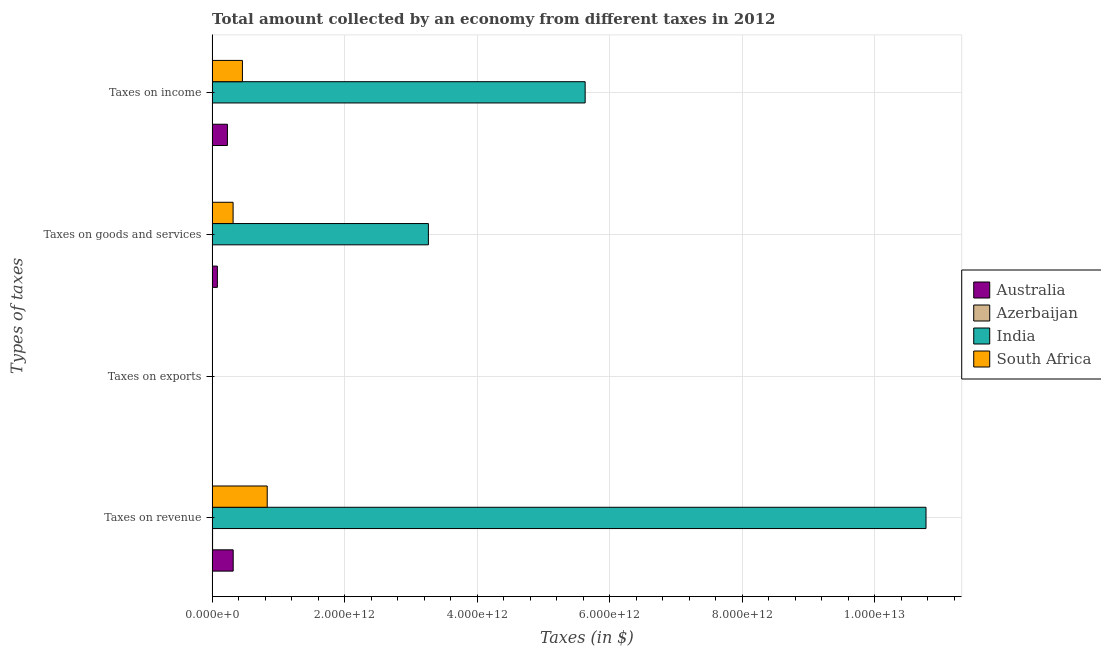How many different coloured bars are there?
Your answer should be compact. 4. How many groups of bars are there?
Offer a terse response. 4. How many bars are there on the 3rd tick from the top?
Provide a succinct answer. 4. What is the label of the 4th group of bars from the top?
Offer a terse response. Taxes on revenue. Across all countries, what is the maximum amount collected as tax on exports?
Keep it short and to the point. 7.00e+08. Across all countries, what is the minimum amount collected as tax on exports?
Provide a short and direct response. 8.00e+05. In which country was the amount collected as tax on income maximum?
Offer a very short reply. India. In which country was the amount collected as tax on goods minimum?
Your answer should be very brief. Azerbaijan. What is the total amount collected as tax on revenue in the graph?
Provide a succinct answer. 1.19e+13. What is the difference between the amount collected as tax on revenue in South Africa and that in Australia?
Give a very brief answer. 5.14e+11. What is the difference between the amount collected as tax on exports in South Africa and the amount collected as tax on income in India?
Offer a very short reply. -5.63e+12. What is the average amount collected as tax on revenue per country?
Give a very brief answer. 2.98e+12. What is the difference between the amount collected as tax on income and amount collected as tax on exports in Australia?
Provide a short and direct response. 2.31e+11. In how many countries, is the amount collected as tax on revenue greater than 7200000000000 $?
Offer a terse response. 1. What is the ratio of the amount collected as tax on exports in Australia to that in India?
Offer a terse response. 0.02. What is the difference between the highest and the second highest amount collected as tax on revenue?
Your answer should be very brief. 9.94e+12. What is the difference between the highest and the lowest amount collected as tax on income?
Ensure brevity in your answer.  5.63e+12. In how many countries, is the amount collected as tax on exports greater than the average amount collected as tax on exports taken over all countries?
Make the answer very short. 1. Is it the case that in every country, the sum of the amount collected as tax on income and amount collected as tax on exports is greater than the sum of amount collected as tax on revenue and amount collected as tax on goods?
Provide a succinct answer. No. What does the 4th bar from the top in Taxes on revenue represents?
Provide a short and direct response. Australia. Is it the case that in every country, the sum of the amount collected as tax on revenue and amount collected as tax on exports is greater than the amount collected as tax on goods?
Give a very brief answer. Yes. Are all the bars in the graph horizontal?
Your answer should be very brief. Yes. What is the difference between two consecutive major ticks on the X-axis?
Give a very brief answer. 2.00e+12. Does the graph contain any zero values?
Provide a short and direct response. No. Does the graph contain grids?
Give a very brief answer. Yes. How many legend labels are there?
Keep it short and to the point. 4. What is the title of the graph?
Ensure brevity in your answer.  Total amount collected by an economy from different taxes in 2012. What is the label or title of the X-axis?
Offer a very short reply. Taxes (in $). What is the label or title of the Y-axis?
Provide a succinct answer. Types of taxes. What is the Taxes (in $) in Australia in Taxes on revenue?
Offer a very short reply. 3.18e+11. What is the Taxes (in $) in Azerbaijan in Taxes on revenue?
Provide a succinct answer. 7.00e+09. What is the Taxes (in $) in India in Taxes on revenue?
Your answer should be compact. 1.08e+13. What is the Taxes (in $) in South Africa in Taxes on revenue?
Your response must be concise. 8.32e+11. What is the Taxes (in $) of India in Taxes on exports?
Give a very brief answer. 7.00e+08. What is the Taxes (in $) in South Africa in Taxes on exports?
Provide a succinct answer. 5.54e+07. What is the Taxes (in $) of Australia in Taxes on goods and services?
Your answer should be very brief. 7.94e+1. What is the Taxes (in $) in Azerbaijan in Taxes on goods and services?
Give a very brief answer. 3.08e+09. What is the Taxes (in $) of India in Taxes on goods and services?
Your answer should be compact. 3.26e+12. What is the Taxes (in $) in South Africa in Taxes on goods and services?
Your answer should be very brief. 3.17e+11. What is the Taxes (in $) in Australia in Taxes on income?
Provide a succinct answer. 2.31e+11. What is the Taxes (in $) in Azerbaijan in Taxes on income?
Your response must be concise. 3.07e+09. What is the Taxes (in $) of India in Taxes on income?
Your response must be concise. 5.63e+12. What is the Taxes (in $) in South Africa in Taxes on income?
Keep it short and to the point. 4.57e+11. Across all Types of taxes, what is the maximum Taxes (in $) of Australia?
Your answer should be compact. 3.18e+11. Across all Types of taxes, what is the maximum Taxes (in $) of Azerbaijan?
Offer a terse response. 7.00e+09. Across all Types of taxes, what is the maximum Taxes (in $) of India?
Ensure brevity in your answer.  1.08e+13. Across all Types of taxes, what is the maximum Taxes (in $) in South Africa?
Your response must be concise. 8.32e+11. Across all Types of taxes, what is the minimum Taxes (in $) of India?
Ensure brevity in your answer.  7.00e+08. Across all Types of taxes, what is the minimum Taxes (in $) in South Africa?
Keep it short and to the point. 5.54e+07. What is the total Taxes (in $) in Australia in the graph?
Offer a terse response. 6.28e+11. What is the total Taxes (in $) of Azerbaijan in the graph?
Provide a short and direct response. 1.31e+1. What is the total Taxes (in $) of India in the graph?
Provide a succinct answer. 1.97e+13. What is the total Taxes (in $) of South Africa in the graph?
Offer a very short reply. 1.61e+12. What is the difference between the Taxes (in $) in Australia in Taxes on revenue and that in Taxes on exports?
Your response must be concise. 3.18e+11. What is the difference between the Taxes (in $) of Azerbaijan in Taxes on revenue and that in Taxes on exports?
Keep it short and to the point. 6.99e+09. What is the difference between the Taxes (in $) of India in Taxes on revenue and that in Taxes on exports?
Give a very brief answer. 1.08e+13. What is the difference between the Taxes (in $) of South Africa in Taxes on revenue and that in Taxes on exports?
Keep it short and to the point. 8.32e+11. What is the difference between the Taxes (in $) of Australia in Taxes on revenue and that in Taxes on goods and services?
Provide a succinct answer. 2.39e+11. What is the difference between the Taxes (in $) of Azerbaijan in Taxes on revenue and that in Taxes on goods and services?
Your response must be concise. 3.92e+09. What is the difference between the Taxes (in $) in India in Taxes on revenue and that in Taxes on goods and services?
Your answer should be compact. 7.51e+12. What is the difference between the Taxes (in $) of South Africa in Taxes on revenue and that in Taxes on goods and services?
Ensure brevity in your answer.  5.15e+11. What is the difference between the Taxes (in $) of Australia in Taxes on revenue and that in Taxes on income?
Offer a terse response. 8.70e+1. What is the difference between the Taxes (in $) in Azerbaijan in Taxes on revenue and that in Taxes on income?
Ensure brevity in your answer.  3.92e+09. What is the difference between the Taxes (in $) of India in Taxes on revenue and that in Taxes on income?
Ensure brevity in your answer.  5.15e+12. What is the difference between the Taxes (in $) in South Africa in Taxes on revenue and that in Taxes on income?
Offer a terse response. 3.74e+11. What is the difference between the Taxes (in $) of Australia in Taxes on exports and that in Taxes on goods and services?
Offer a very short reply. -7.93e+1. What is the difference between the Taxes (in $) of Azerbaijan in Taxes on exports and that in Taxes on goods and services?
Keep it short and to the point. -3.08e+09. What is the difference between the Taxes (in $) in India in Taxes on exports and that in Taxes on goods and services?
Offer a terse response. -3.26e+12. What is the difference between the Taxes (in $) of South Africa in Taxes on exports and that in Taxes on goods and services?
Offer a very short reply. -3.16e+11. What is the difference between the Taxes (in $) of Australia in Taxes on exports and that in Taxes on income?
Provide a short and direct response. -2.31e+11. What is the difference between the Taxes (in $) in Azerbaijan in Taxes on exports and that in Taxes on income?
Your answer should be very brief. -3.07e+09. What is the difference between the Taxes (in $) of India in Taxes on exports and that in Taxes on income?
Provide a succinct answer. -5.63e+12. What is the difference between the Taxes (in $) of South Africa in Taxes on exports and that in Taxes on income?
Offer a very short reply. -4.57e+11. What is the difference between the Taxes (in $) in Australia in Taxes on goods and services and that in Taxes on income?
Provide a succinct answer. -1.51e+11. What is the difference between the Taxes (in $) in Azerbaijan in Taxes on goods and services and that in Taxes on income?
Ensure brevity in your answer.  7.40e+06. What is the difference between the Taxes (in $) of India in Taxes on goods and services and that in Taxes on income?
Offer a very short reply. -2.37e+12. What is the difference between the Taxes (in $) in South Africa in Taxes on goods and services and that in Taxes on income?
Ensure brevity in your answer.  -1.41e+11. What is the difference between the Taxes (in $) of Australia in Taxes on revenue and the Taxes (in $) of Azerbaijan in Taxes on exports?
Keep it short and to the point. 3.18e+11. What is the difference between the Taxes (in $) of Australia in Taxes on revenue and the Taxes (in $) of India in Taxes on exports?
Give a very brief answer. 3.17e+11. What is the difference between the Taxes (in $) of Australia in Taxes on revenue and the Taxes (in $) of South Africa in Taxes on exports?
Provide a short and direct response. 3.18e+11. What is the difference between the Taxes (in $) of Azerbaijan in Taxes on revenue and the Taxes (in $) of India in Taxes on exports?
Provide a short and direct response. 6.30e+09. What is the difference between the Taxes (in $) in Azerbaijan in Taxes on revenue and the Taxes (in $) in South Africa in Taxes on exports?
Provide a succinct answer. 6.94e+09. What is the difference between the Taxes (in $) of India in Taxes on revenue and the Taxes (in $) of South Africa in Taxes on exports?
Ensure brevity in your answer.  1.08e+13. What is the difference between the Taxes (in $) of Australia in Taxes on revenue and the Taxes (in $) of Azerbaijan in Taxes on goods and services?
Ensure brevity in your answer.  3.15e+11. What is the difference between the Taxes (in $) of Australia in Taxes on revenue and the Taxes (in $) of India in Taxes on goods and services?
Provide a succinct answer. -2.95e+12. What is the difference between the Taxes (in $) of Australia in Taxes on revenue and the Taxes (in $) of South Africa in Taxes on goods and services?
Make the answer very short. 1.33e+09. What is the difference between the Taxes (in $) in Azerbaijan in Taxes on revenue and the Taxes (in $) in India in Taxes on goods and services?
Give a very brief answer. -3.26e+12. What is the difference between the Taxes (in $) of Azerbaijan in Taxes on revenue and the Taxes (in $) of South Africa in Taxes on goods and services?
Give a very brief answer. -3.10e+11. What is the difference between the Taxes (in $) of India in Taxes on revenue and the Taxes (in $) of South Africa in Taxes on goods and services?
Ensure brevity in your answer.  1.05e+13. What is the difference between the Taxes (in $) in Australia in Taxes on revenue and the Taxes (in $) in Azerbaijan in Taxes on income?
Give a very brief answer. 3.15e+11. What is the difference between the Taxes (in $) of Australia in Taxes on revenue and the Taxes (in $) of India in Taxes on income?
Provide a short and direct response. -5.31e+12. What is the difference between the Taxes (in $) of Australia in Taxes on revenue and the Taxes (in $) of South Africa in Taxes on income?
Ensure brevity in your answer.  -1.39e+11. What is the difference between the Taxes (in $) of Azerbaijan in Taxes on revenue and the Taxes (in $) of India in Taxes on income?
Make the answer very short. -5.62e+12. What is the difference between the Taxes (in $) of Azerbaijan in Taxes on revenue and the Taxes (in $) of South Africa in Taxes on income?
Provide a succinct answer. -4.50e+11. What is the difference between the Taxes (in $) of India in Taxes on revenue and the Taxes (in $) of South Africa in Taxes on income?
Provide a succinct answer. 1.03e+13. What is the difference between the Taxes (in $) of Australia in Taxes on exports and the Taxes (in $) of Azerbaijan in Taxes on goods and services?
Your answer should be very brief. -3.07e+09. What is the difference between the Taxes (in $) in Australia in Taxes on exports and the Taxes (in $) in India in Taxes on goods and services?
Make the answer very short. -3.26e+12. What is the difference between the Taxes (in $) in Australia in Taxes on exports and the Taxes (in $) in South Africa in Taxes on goods and services?
Provide a short and direct response. -3.17e+11. What is the difference between the Taxes (in $) in Azerbaijan in Taxes on exports and the Taxes (in $) in India in Taxes on goods and services?
Your answer should be very brief. -3.26e+12. What is the difference between the Taxes (in $) of Azerbaijan in Taxes on exports and the Taxes (in $) of South Africa in Taxes on goods and services?
Your answer should be very brief. -3.17e+11. What is the difference between the Taxes (in $) of India in Taxes on exports and the Taxes (in $) of South Africa in Taxes on goods and services?
Give a very brief answer. -3.16e+11. What is the difference between the Taxes (in $) of Australia in Taxes on exports and the Taxes (in $) of Azerbaijan in Taxes on income?
Provide a succinct answer. -3.06e+09. What is the difference between the Taxes (in $) in Australia in Taxes on exports and the Taxes (in $) in India in Taxes on income?
Ensure brevity in your answer.  -5.63e+12. What is the difference between the Taxes (in $) in Australia in Taxes on exports and the Taxes (in $) in South Africa in Taxes on income?
Make the answer very short. -4.57e+11. What is the difference between the Taxes (in $) of Azerbaijan in Taxes on exports and the Taxes (in $) of India in Taxes on income?
Keep it short and to the point. -5.63e+12. What is the difference between the Taxes (in $) in Azerbaijan in Taxes on exports and the Taxes (in $) in South Africa in Taxes on income?
Offer a terse response. -4.57e+11. What is the difference between the Taxes (in $) in India in Taxes on exports and the Taxes (in $) in South Africa in Taxes on income?
Provide a short and direct response. -4.57e+11. What is the difference between the Taxes (in $) of Australia in Taxes on goods and services and the Taxes (in $) of Azerbaijan in Taxes on income?
Your answer should be very brief. 7.63e+1. What is the difference between the Taxes (in $) in Australia in Taxes on goods and services and the Taxes (in $) in India in Taxes on income?
Give a very brief answer. -5.55e+12. What is the difference between the Taxes (in $) in Australia in Taxes on goods and services and the Taxes (in $) in South Africa in Taxes on income?
Give a very brief answer. -3.78e+11. What is the difference between the Taxes (in $) in Azerbaijan in Taxes on goods and services and the Taxes (in $) in India in Taxes on income?
Ensure brevity in your answer.  -5.63e+12. What is the difference between the Taxes (in $) in Azerbaijan in Taxes on goods and services and the Taxes (in $) in South Africa in Taxes on income?
Your response must be concise. -4.54e+11. What is the difference between the Taxes (in $) of India in Taxes on goods and services and the Taxes (in $) of South Africa in Taxes on income?
Keep it short and to the point. 2.81e+12. What is the average Taxes (in $) of Australia per Types of taxes?
Provide a short and direct response. 1.57e+11. What is the average Taxes (in $) of Azerbaijan per Types of taxes?
Provide a succinct answer. 3.29e+09. What is the average Taxes (in $) in India per Types of taxes?
Keep it short and to the point. 4.92e+12. What is the average Taxes (in $) in South Africa per Types of taxes?
Make the answer very short. 4.01e+11. What is the difference between the Taxes (in $) in Australia and Taxes (in $) in Azerbaijan in Taxes on revenue?
Make the answer very short. 3.11e+11. What is the difference between the Taxes (in $) of Australia and Taxes (in $) of India in Taxes on revenue?
Give a very brief answer. -1.05e+13. What is the difference between the Taxes (in $) in Australia and Taxes (in $) in South Africa in Taxes on revenue?
Offer a terse response. -5.14e+11. What is the difference between the Taxes (in $) in Azerbaijan and Taxes (in $) in India in Taxes on revenue?
Provide a short and direct response. -1.08e+13. What is the difference between the Taxes (in $) of Azerbaijan and Taxes (in $) of South Africa in Taxes on revenue?
Keep it short and to the point. -8.25e+11. What is the difference between the Taxes (in $) of India and Taxes (in $) of South Africa in Taxes on revenue?
Make the answer very short. 9.94e+12. What is the difference between the Taxes (in $) in Australia and Taxes (in $) in Azerbaijan in Taxes on exports?
Make the answer very short. 1.12e+07. What is the difference between the Taxes (in $) in Australia and Taxes (in $) in India in Taxes on exports?
Your response must be concise. -6.88e+08. What is the difference between the Taxes (in $) in Australia and Taxes (in $) in South Africa in Taxes on exports?
Your response must be concise. -4.34e+07. What is the difference between the Taxes (in $) of Azerbaijan and Taxes (in $) of India in Taxes on exports?
Offer a very short reply. -6.99e+08. What is the difference between the Taxes (in $) of Azerbaijan and Taxes (in $) of South Africa in Taxes on exports?
Provide a short and direct response. -5.46e+07. What is the difference between the Taxes (in $) of India and Taxes (in $) of South Africa in Taxes on exports?
Your response must be concise. 6.45e+08. What is the difference between the Taxes (in $) in Australia and Taxes (in $) in Azerbaijan in Taxes on goods and services?
Provide a succinct answer. 7.63e+1. What is the difference between the Taxes (in $) of Australia and Taxes (in $) of India in Taxes on goods and services?
Ensure brevity in your answer.  -3.19e+12. What is the difference between the Taxes (in $) in Australia and Taxes (in $) in South Africa in Taxes on goods and services?
Provide a short and direct response. -2.37e+11. What is the difference between the Taxes (in $) in Azerbaijan and Taxes (in $) in India in Taxes on goods and services?
Give a very brief answer. -3.26e+12. What is the difference between the Taxes (in $) of Azerbaijan and Taxes (in $) of South Africa in Taxes on goods and services?
Provide a succinct answer. -3.13e+11. What is the difference between the Taxes (in $) of India and Taxes (in $) of South Africa in Taxes on goods and services?
Offer a terse response. 2.95e+12. What is the difference between the Taxes (in $) of Australia and Taxes (in $) of Azerbaijan in Taxes on income?
Your response must be concise. 2.28e+11. What is the difference between the Taxes (in $) in Australia and Taxes (in $) in India in Taxes on income?
Ensure brevity in your answer.  -5.40e+12. What is the difference between the Taxes (in $) in Australia and Taxes (in $) in South Africa in Taxes on income?
Offer a terse response. -2.26e+11. What is the difference between the Taxes (in $) of Azerbaijan and Taxes (in $) of India in Taxes on income?
Provide a short and direct response. -5.63e+12. What is the difference between the Taxes (in $) of Azerbaijan and Taxes (in $) of South Africa in Taxes on income?
Offer a terse response. -4.54e+11. What is the difference between the Taxes (in $) of India and Taxes (in $) of South Africa in Taxes on income?
Make the answer very short. 5.17e+12. What is the ratio of the Taxes (in $) in Australia in Taxes on revenue to that in Taxes on exports?
Provide a short and direct response. 2.65e+04. What is the ratio of the Taxes (in $) of Azerbaijan in Taxes on revenue to that in Taxes on exports?
Keep it short and to the point. 8744.38. What is the ratio of the Taxes (in $) of India in Taxes on revenue to that in Taxes on exports?
Offer a terse response. 1.54e+04. What is the ratio of the Taxes (in $) of South Africa in Taxes on revenue to that in Taxes on exports?
Ensure brevity in your answer.  1.50e+04. What is the ratio of the Taxes (in $) in Australia in Taxes on revenue to that in Taxes on goods and services?
Make the answer very short. 4.01. What is the ratio of the Taxes (in $) in Azerbaijan in Taxes on revenue to that in Taxes on goods and services?
Offer a terse response. 2.27. What is the ratio of the Taxes (in $) of India in Taxes on revenue to that in Taxes on goods and services?
Make the answer very short. 3.3. What is the ratio of the Taxes (in $) in South Africa in Taxes on revenue to that in Taxes on goods and services?
Your response must be concise. 2.63. What is the ratio of the Taxes (in $) of Australia in Taxes on revenue to that in Taxes on income?
Give a very brief answer. 1.38. What is the ratio of the Taxes (in $) in Azerbaijan in Taxes on revenue to that in Taxes on income?
Provide a succinct answer. 2.28. What is the ratio of the Taxes (in $) in India in Taxes on revenue to that in Taxes on income?
Your response must be concise. 1.91. What is the ratio of the Taxes (in $) of South Africa in Taxes on revenue to that in Taxes on income?
Offer a terse response. 1.82. What is the ratio of the Taxes (in $) in Azerbaijan in Taxes on exports to that in Taxes on goods and services?
Your answer should be compact. 0. What is the ratio of the Taxes (in $) in South Africa in Taxes on exports to that in Taxes on goods and services?
Offer a terse response. 0. What is the ratio of the Taxes (in $) in Australia in Taxes on exports to that in Taxes on income?
Your response must be concise. 0. What is the ratio of the Taxes (in $) of Azerbaijan in Taxes on exports to that in Taxes on income?
Provide a succinct answer. 0. What is the ratio of the Taxes (in $) of South Africa in Taxes on exports to that in Taxes on income?
Your answer should be very brief. 0. What is the ratio of the Taxes (in $) of Australia in Taxes on goods and services to that in Taxes on income?
Your answer should be compact. 0.34. What is the ratio of the Taxes (in $) in Azerbaijan in Taxes on goods and services to that in Taxes on income?
Make the answer very short. 1. What is the ratio of the Taxes (in $) of India in Taxes on goods and services to that in Taxes on income?
Give a very brief answer. 0.58. What is the ratio of the Taxes (in $) in South Africa in Taxes on goods and services to that in Taxes on income?
Provide a succinct answer. 0.69. What is the difference between the highest and the second highest Taxes (in $) in Australia?
Make the answer very short. 8.70e+1. What is the difference between the highest and the second highest Taxes (in $) in Azerbaijan?
Your answer should be compact. 3.92e+09. What is the difference between the highest and the second highest Taxes (in $) in India?
Your answer should be compact. 5.15e+12. What is the difference between the highest and the second highest Taxes (in $) in South Africa?
Offer a terse response. 3.74e+11. What is the difference between the highest and the lowest Taxes (in $) in Australia?
Your answer should be very brief. 3.18e+11. What is the difference between the highest and the lowest Taxes (in $) of Azerbaijan?
Make the answer very short. 6.99e+09. What is the difference between the highest and the lowest Taxes (in $) of India?
Give a very brief answer. 1.08e+13. What is the difference between the highest and the lowest Taxes (in $) in South Africa?
Give a very brief answer. 8.32e+11. 